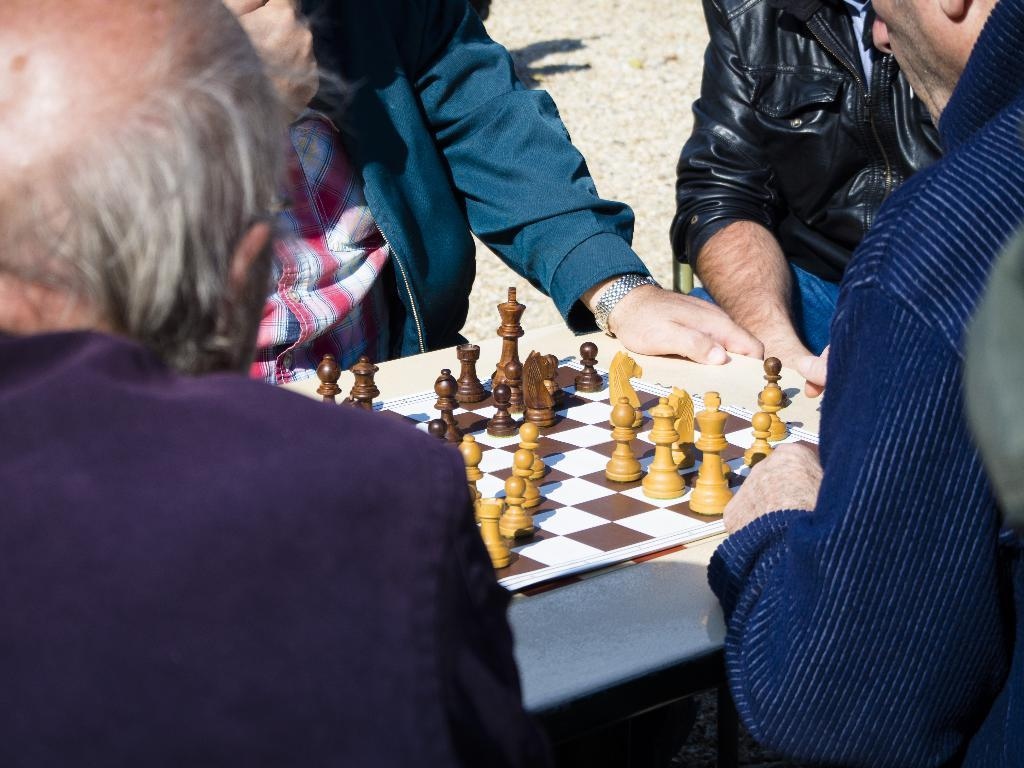What is happening in the image? There is a group of people in the image, and they are playing chess. How many people are involved in the activity? The number of people involved in the activity is not specified, but there is a group of people playing chess. What type of insurance policy do the people playing chess have in the image? There is no information about insurance policies in the image; it features a group of people playing chess. What love verse is being recited by the people playing chess in the image? There is no mention of a love verse or any recitation in the image; it simply shows a group of people playing chess. 